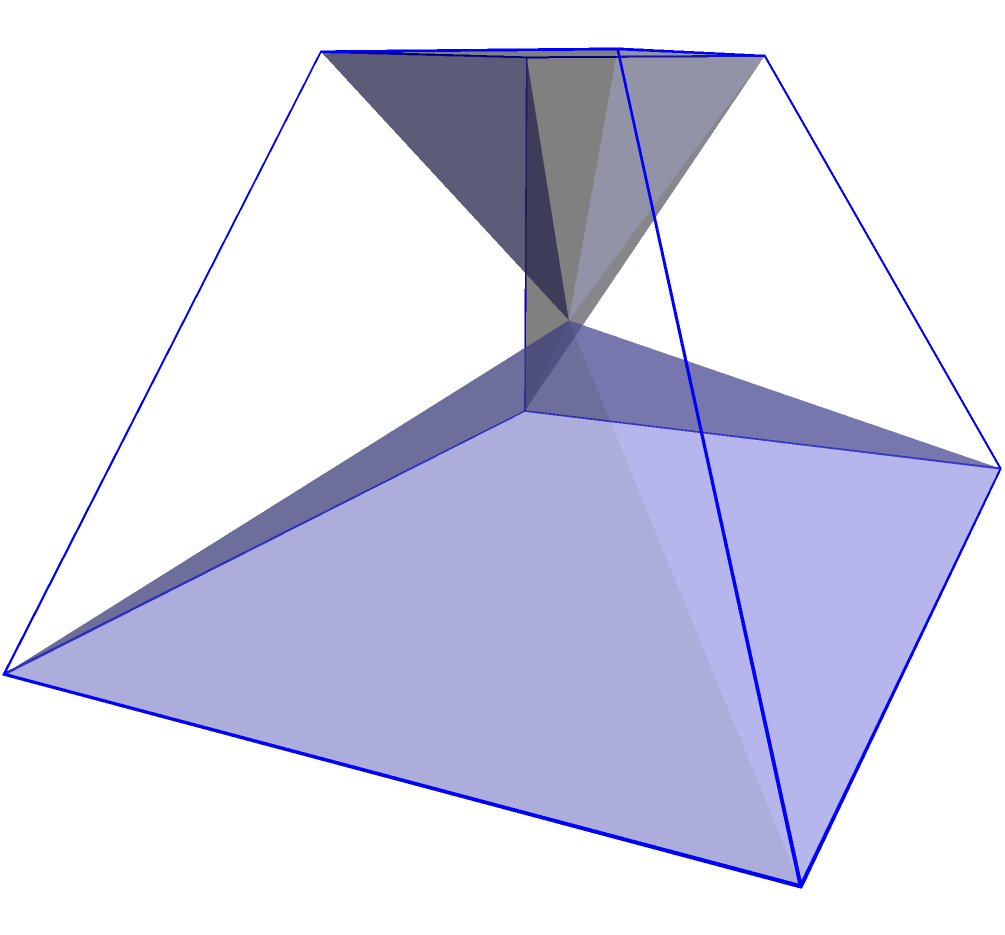A unique soundboard for a Mongolian orchestra is designed in the shape of a truncated pyramid. The base measures 6 cm by 4 cm, the top surface measures 3 cm by 2 cm, and the height is 3 cm. Calculate the volume of this soundboard, drawing inspiration from the geometric precision found in Hungarian composer Béla Bartók's works. To calculate the volume of a truncated pyramid, we'll use the formula:

$$V = \frac{1}{3}h(A_1 + A_2 + \sqrt{A_1A_2})$$

Where:
$V$ = Volume
$h$ = Height
$A_1$ = Area of the base
$A_2$ = Area of the top surface

Step 1: Calculate the area of the base ($A_1$)
$A_1 = 6 \text{ cm} \times 4 \text{ cm} = 24 \text{ cm}^2$

Step 2: Calculate the area of the top surface ($A_2$)
$A_2 = 3 \text{ cm} \times 2 \text{ cm} = 6 \text{ cm}^2$

Step 3: Calculate $\sqrt{A_1A_2}$
$\sqrt{A_1A_2} = \sqrt{24 \text{ cm}^2 \times 6 \text{ cm}^2} = \sqrt{144 \text{ cm}^4} = 12 \text{ cm}^2$

Step 4: Apply the formula
$V = \frac{1}{3} \times 3 \text{ cm} \times (24 \text{ cm}^2 + 6 \text{ cm}^2 + 12 \text{ cm}^2)$
$V = 1 \text{ cm} \times 42 \text{ cm}^2 = 42 \text{ cm}^3$

Therefore, the volume of the truncated pyramid-shaped soundboard is 42 cubic centimeters.
Answer: 42 cm³ 